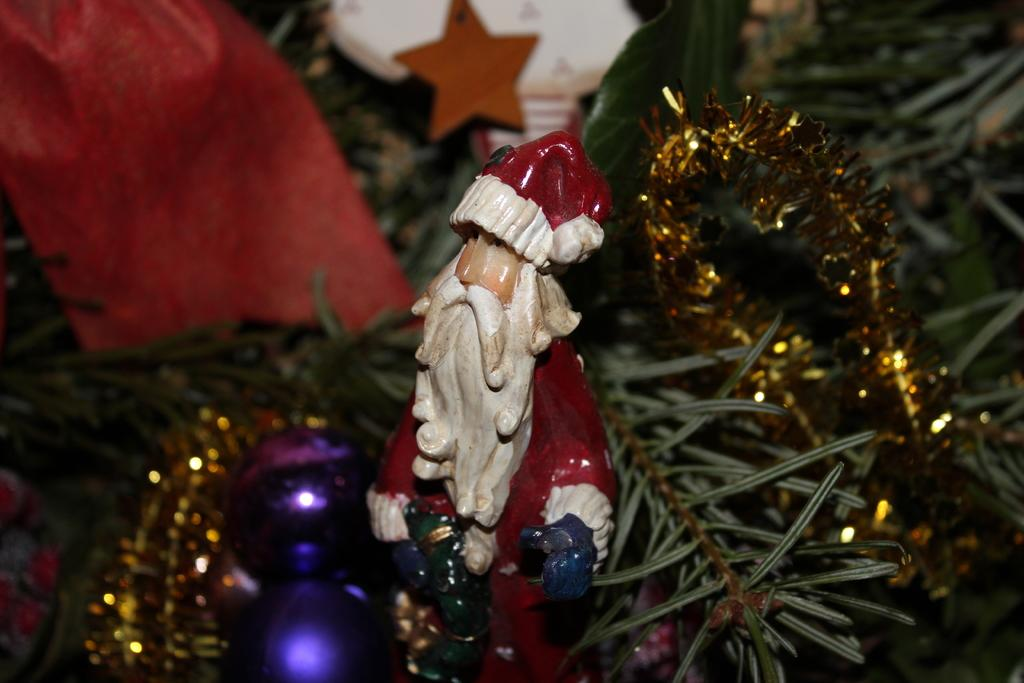What is the main subject of the image? There is a statue of Santa Claus in the image. What colors are used for the Santa Claus statue? The statue is red, white, and cream in color. What other items can be seen in the image besides the Santa Claus statue? There are decorative items, a tree, and a light in the image. What type of drink is Santa Claus holding in the image? There is no drink visible in the image; Santa Claus is a statue and does not hold any objects. 